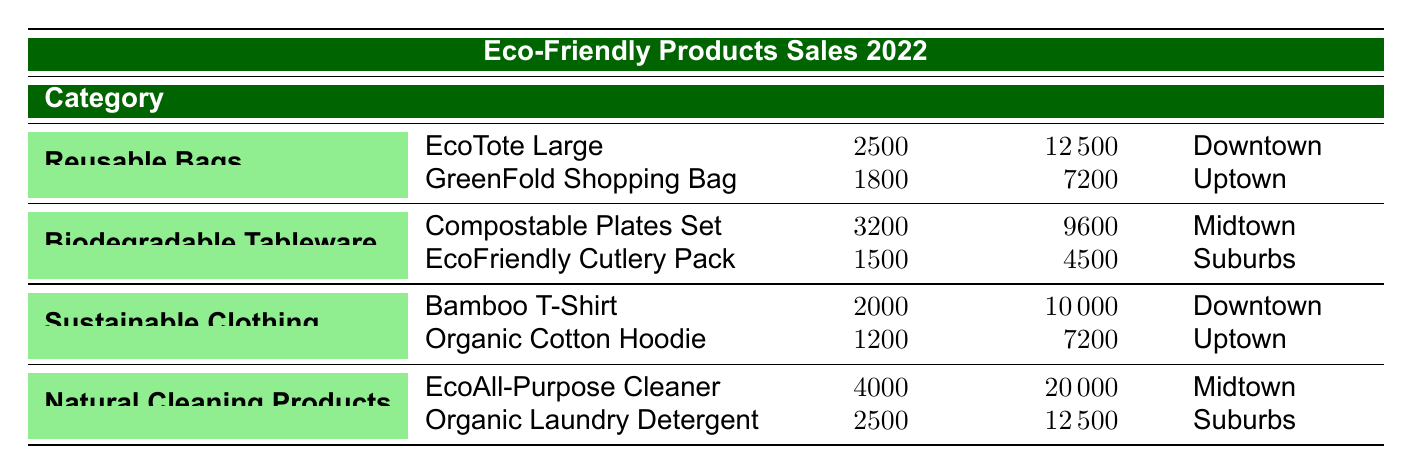What is the total sales volume for the category "Natural Cleaning Products"? To find the total sales volume for "Natural Cleaning Products," I need to sum the sales volume of both products in that category: 4000 (EcoAll-Purpose Cleaner) + 2500 (Organic Laundry Detergent) = 6500.
Answer: 6500 Which product generated the highest revenue in the "Biodegradable Tableware" category? In the "Biodegradable Tableware" category, the revenue for the products are: Compostable Plates Set is 9600 and EcoFriendly Cutlery Pack is 4500. The higher value is 9600.
Answer: Compostable Plates Set Is the total revenue for "Reusable Bags" greater than that of "Sustainable Clothing"? First, calculate the total revenue for "Reusable Bags": 12500 + 7200 = 19700. Now for "Sustainable Clothing": 10000 + 7200 = 17200. Since 19700 > 17200, the answer is yes.
Answer: Yes What is the average sales volume for all the products listed in the table? To get the average sales volume, sum all the sales volumes: 2500 + 1800 + 3200 + 1500 + 2000 + 1200 + 4000 + 2500 = 18700. Then, divide by the number of products (8): 18700 / 8 = 2337.5.
Answer: 2337.5 How many products were sold in the "Downtown" sales region? From the table, in the "Downtown" region, there are two products: EcoTote Large and Bamboo T-Shirt. Therefore, the count is 2.
Answer: 2 Which sales region had the highest revenue for eco-friendly products? The total revenue by sales region: Downtown = 12500 + 10000 = 22500, Uptown = 7200 + 7200 = 14400, Midtown = 9600 + 20000 = 29600, Suburbs = 4500 + 12500 = 17000. The highest is Midtown with 29600.
Answer: Midtown Is the revenue from "EcoAll-Purpose Cleaner" equal to the revenue from "Organic Laundry Detergent"? The revenue for EcoAll-Purpose Cleaner is 20000 and for Organic Laundry Detergent is 12500. Since 20000 is not equal to 12500, the answer is no.
Answer: No What is the difference in sales volume between the best-selling product in "Natural Cleaning Products" and the worst-selling product in the table? The best-selling product in "Natural Cleaning Products" is EcoAll-Purpose Cleaner with 4000 units. The worst-selling product in the table is the Organic Cotton Hoodie with 1200 units. The difference is 4000 - 1200 = 2800.
Answer: 2800 